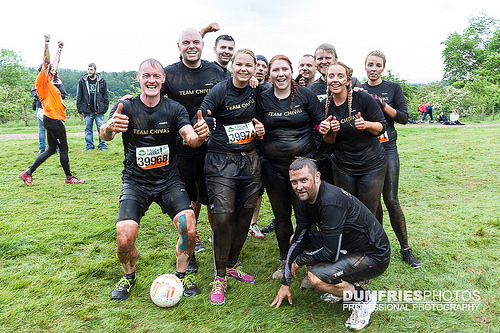<image>
Is there a man behind the woman? Yes. From this viewpoint, the man is positioned behind the woman, with the woman partially or fully occluding the man. Is there a football next to the woman? Yes. The football is positioned adjacent to the woman, located nearby in the same general area. 